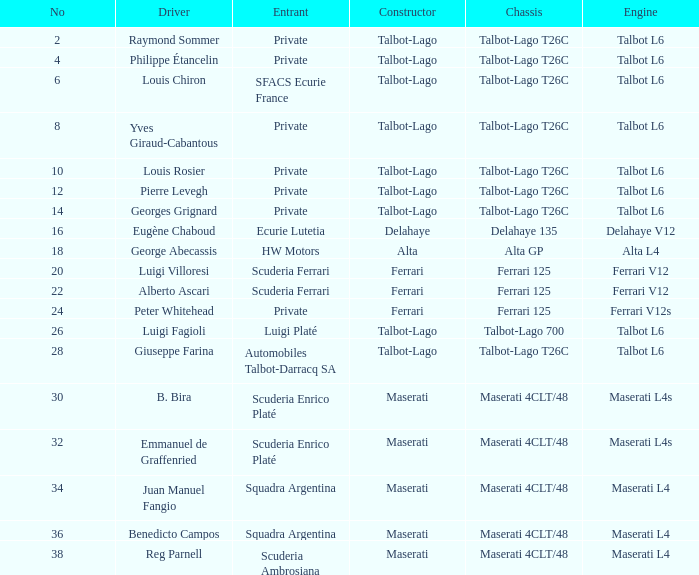What is the constructor called for b. bira? Maserati. 